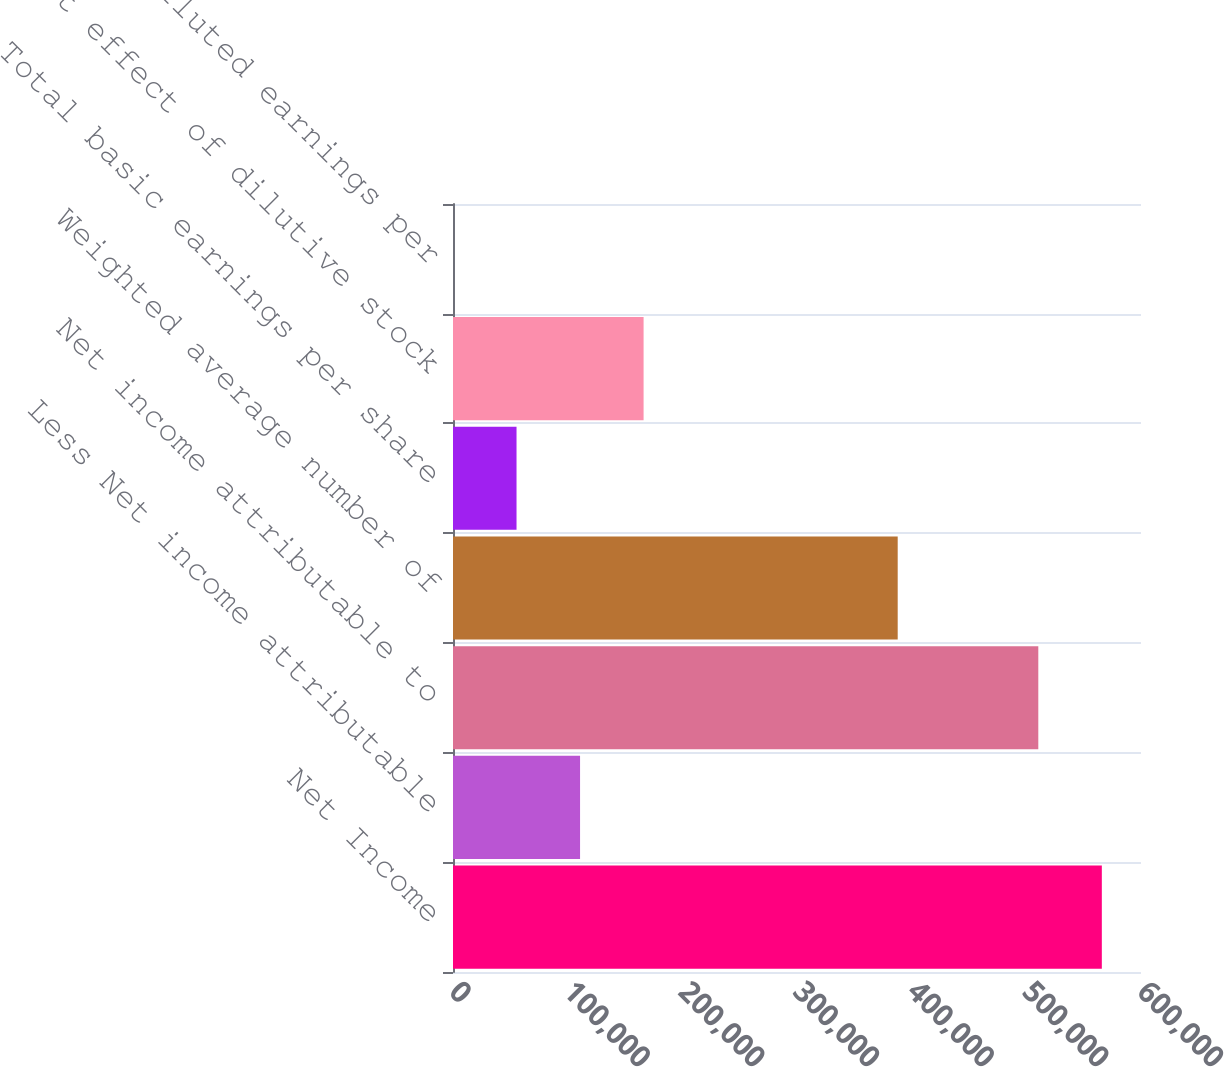<chart> <loc_0><loc_0><loc_500><loc_500><bar_chart><fcel>Net Income<fcel>Less Net income attributable<fcel>Net income attributable to<fcel>Weighted average number of<fcel>Total basic earnings per share<fcel>Net effect of dilutive stock<fcel>Total diluted earnings per<nl><fcel>565841<fcel>110809<fcel>510439<fcel>387818<fcel>55406.9<fcel>166211<fcel>5.14<nl></chart> 